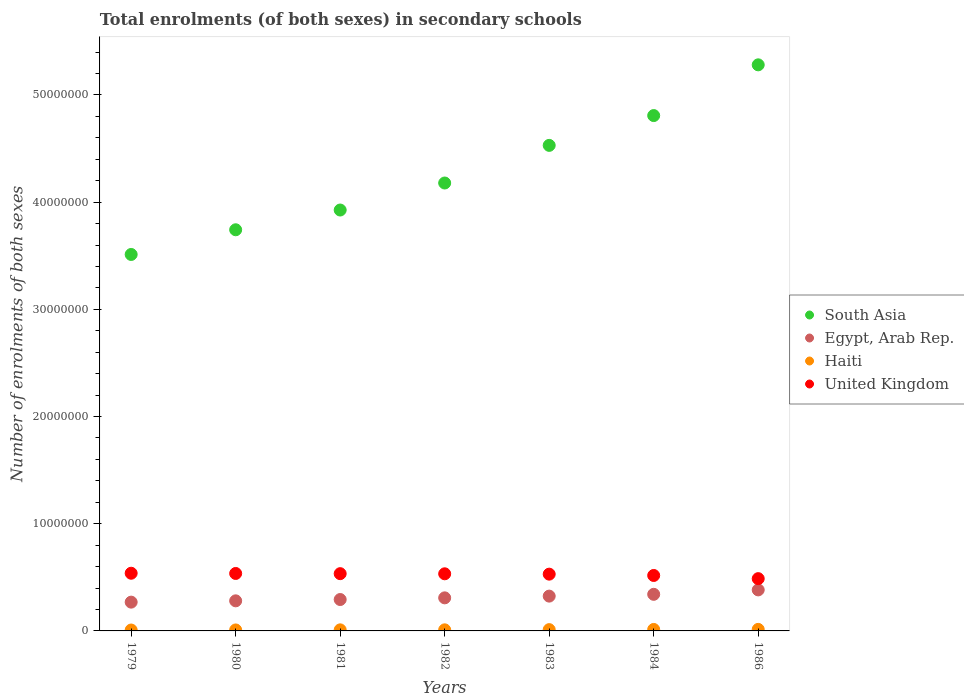Is the number of dotlines equal to the number of legend labels?
Offer a very short reply. Yes. What is the number of enrolments in secondary schools in Haiti in 1981?
Keep it short and to the point. 9.99e+04. Across all years, what is the maximum number of enrolments in secondary schools in Egypt, Arab Rep.?
Your response must be concise. 3.83e+06. Across all years, what is the minimum number of enrolments in secondary schools in United Kingdom?
Your answer should be very brief. 4.88e+06. In which year was the number of enrolments in secondary schools in South Asia maximum?
Your answer should be compact. 1986. In which year was the number of enrolments in secondary schools in Egypt, Arab Rep. minimum?
Make the answer very short. 1979. What is the total number of enrolments in secondary schools in South Asia in the graph?
Offer a very short reply. 3.00e+08. What is the difference between the number of enrolments in secondary schools in Egypt, Arab Rep. in 1982 and that in 1984?
Your response must be concise. -3.29e+05. What is the difference between the number of enrolments in secondary schools in South Asia in 1984 and the number of enrolments in secondary schools in Haiti in 1983?
Your answer should be very brief. 4.80e+07. What is the average number of enrolments in secondary schools in Haiti per year?
Your answer should be very brief. 1.11e+05. In the year 1981, what is the difference between the number of enrolments in secondary schools in Haiti and number of enrolments in secondary schools in Egypt, Arab Rep.?
Your answer should be compact. -2.83e+06. In how many years, is the number of enrolments in secondary schools in United Kingdom greater than 50000000?
Your answer should be very brief. 0. What is the ratio of the number of enrolments in secondary schools in South Asia in 1982 to that in 1983?
Make the answer very short. 0.92. What is the difference between the highest and the second highest number of enrolments in secondary schools in Egypt, Arab Rep.?
Your response must be concise. 4.12e+05. What is the difference between the highest and the lowest number of enrolments in secondary schools in Haiti?
Provide a succinct answer. 5.93e+04. In how many years, is the number of enrolments in secondary schools in Egypt, Arab Rep. greater than the average number of enrolments in secondary schools in Egypt, Arab Rep. taken over all years?
Provide a succinct answer. 3. Is it the case that in every year, the sum of the number of enrolments in secondary schools in United Kingdom and number of enrolments in secondary schools in Haiti  is greater than the sum of number of enrolments in secondary schools in South Asia and number of enrolments in secondary schools in Egypt, Arab Rep.?
Offer a very short reply. No. How many years are there in the graph?
Offer a very short reply. 7. Are the values on the major ticks of Y-axis written in scientific E-notation?
Your response must be concise. No. Does the graph contain any zero values?
Provide a succinct answer. No. Does the graph contain grids?
Your response must be concise. No. How many legend labels are there?
Ensure brevity in your answer.  4. How are the legend labels stacked?
Ensure brevity in your answer.  Vertical. What is the title of the graph?
Give a very brief answer. Total enrolments (of both sexes) in secondary schools. Does "Uganda" appear as one of the legend labels in the graph?
Your answer should be very brief. No. What is the label or title of the Y-axis?
Provide a short and direct response. Number of enrolments of both sexes. What is the Number of enrolments of both sexes of South Asia in 1979?
Provide a succinct answer. 3.51e+07. What is the Number of enrolments of both sexes in Egypt, Arab Rep. in 1979?
Provide a short and direct response. 2.69e+06. What is the Number of enrolments of both sexes of Haiti in 1979?
Give a very brief answer. 8.45e+04. What is the Number of enrolments of both sexes of United Kingdom in 1979?
Make the answer very short. 5.38e+06. What is the Number of enrolments of both sexes in South Asia in 1980?
Ensure brevity in your answer.  3.74e+07. What is the Number of enrolments of both sexes in Egypt, Arab Rep. in 1980?
Your response must be concise. 2.81e+06. What is the Number of enrolments of both sexes of Haiti in 1980?
Offer a very short reply. 9.12e+04. What is the Number of enrolments of both sexes in United Kingdom in 1980?
Offer a very short reply. 5.36e+06. What is the Number of enrolments of both sexes of South Asia in 1981?
Offer a terse response. 3.93e+07. What is the Number of enrolments of both sexes in Egypt, Arab Rep. in 1981?
Offer a very short reply. 2.93e+06. What is the Number of enrolments of both sexes of Haiti in 1981?
Your answer should be compact. 9.99e+04. What is the Number of enrolments of both sexes of United Kingdom in 1981?
Offer a very short reply. 5.34e+06. What is the Number of enrolments of both sexes of South Asia in 1982?
Keep it short and to the point. 4.18e+07. What is the Number of enrolments of both sexes of Egypt, Arab Rep. in 1982?
Provide a short and direct response. 3.09e+06. What is the Number of enrolments of both sexes of Haiti in 1982?
Keep it short and to the point. 1.02e+05. What is the Number of enrolments of both sexes in United Kingdom in 1982?
Offer a very short reply. 5.33e+06. What is the Number of enrolments of both sexes of South Asia in 1983?
Keep it short and to the point. 4.53e+07. What is the Number of enrolments of both sexes in Egypt, Arab Rep. in 1983?
Your answer should be very brief. 3.25e+06. What is the Number of enrolments of both sexes of Haiti in 1983?
Give a very brief answer. 1.20e+05. What is the Number of enrolments of both sexes of United Kingdom in 1983?
Your answer should be compact. 5.30e+06. What is the Number of enrolments of both sexes in South Asia in 1984?
Make the answer very short. 4.81e+07. What is the Number of enrolments of both sexes in Egypt, Arab Rep. in 1984?
Your answer should be compact. 3.41e+06. What is the Number of enrolments of both sexes in Haiti in 1984?
Give a very brief answer. 1.38e+05. What is the Number of enrolments of both sexes in United Kingdom in 1984?
Offer a very short reply. 5.17e+06. What is the Number of enrolments of both sexes in South Asia in 1986?
Ensure brevity in your answer.  5.28e+07. What is the Number of enrolments of both sexes of Egypt, Arab Rep. in 1986?
Offer a terse response. 3.83e+06. What is the Number of enrolments of both sexes of Haiti in 1986?
Provide a succinct answer. 1.44e+05. What is the Number of enrolments of both sexes in United Kingdom in 1986?
Give a very brief answer. 4.88e+06. Across all years, what is the maximum Number of enrolments of both sexes of South Asia?
Make the answer very short. 5.28e+07. Across all years, what is the maximum Number of enrolments of both sexes of Egypt, Arab Rep.?
Ensure brevity in your answer.  3.83e+06. Across all years, what is the maximum Number of enrolments of both sexes in Haiti?
Provide a succinct answer. 1.44e+05. Across all years, what is the maximum Number of enrolments of both sexes of United Kingdom?
Give a very brief answer. 5.38e+06. Across all years, what is the minimum Number of enrolments of both sexes in South Asia?
Offer a terse response. 3.51e+07. Across all years, what is the minimum Number of enrolments of both sexes in Egypt, Arab Rep.?
Offer a terse response. 2.69e+06. Across all years, what is the minimum Number of enrolments of both sexes of Haiti?
Keep it short and to the point. 8.45e+04. Across all years, what is the minimum Number of enrolments of both sexes of United Kingdom?
Make the answer very short. 4.88e+06. What is the total Number of enrolments of both sexes in South Asia in the graph?
Ensure brevity in your answer.  3.00e+08. What is the total Number of enrolments of both sexes in Egypt, Arab Rep. in the graph?
Provide a succinct answer. 2.20e+07. What is the total Number of enrolments of both sexes of Haiti in the graph?
Ensure brevity in your answer.  7.79e+05. What is the total Number of enrolments of both sexes in United Kingdom in the graph?
Make the answer very short. 3.68e+07. What is the difference between the Number of enrolments of both sexes of South Asia in 1979 and that in 1980?
Offer a terse response. -2.30e+06. What is the difference between the Number of enrolments of both sexes in Egypt, Arab Rep. in 1979 and that in 1980?
Give a very brief answer. -1.22e+05. What is the difference between the Number of enrolments of both sexes of Haiti in 1979 and that in 1980?
Your answer should be very brief. -6793. What is the difference between the Number of enrolments of both sexes of United Kingdom in 1979 and that in 1980?
Provide a succinct answer. 2.07e+04. What is the difference between the Number of enrolments of both sexes in South Asia in 1979 and that in 1981?
Ensure brevity in your answer.  -4.15e+06. What is the difference between the Number of enrolments of both sexes in Egypt, Arab Rep. in 1979 and that in 1981?
Ensure brevity in your answer.  -2.44e+05. What is the difference between the Number of enrolments of both sexes of Haiti in 1979 and that in 1981?
Your answer should be very brief. -1.54e+04. What is the difference between the Number of enrolments of both sexes of United Kingdom in 1979 and that in 1981?
Offer a very short reply. 3.89e+04. What is the difference between the Number of enrolments of both sexes of South Asia in 1979 and that in 1982?
Your answer should be very brief. -6.67e+06. What is the difference between the Number of enrolments of both sexes in Egypt, Arab Rep. in 1979 and that in 1982?
Provide a short and direct response. -4.00e+05. What is the difference between the Number of enrolments of both sexes of Haiti in 1979 and that in 1982?
Make the answer very short. -1.71e+04. What is the difference between the Number of enrolments of both sexes in United Kingdom in 1979 and that in 1982?
Your response must be concise. 5.15e+04. What is the difference between the Number of enrolments of both sexes of South Asia in 1979 and that in 1983?
Ensure brevity in your answer.  -1.02e+07. What is the difference between the Number of enrolments of both sexes in Egypt, Arab Rep. in 1979 and that in 1983?
Your answer should be very brief. -5.61e+05. What is the difference between the Number of enrolments of both sexes of Haiti in 1979 and that in 1983?
Provide a succinct answer. -3.59e+04. What is the difference between the Number of enrolments of both sexes in United Kingdom in 1979 and that in 1983?
Provide a short and direct response. 8.48e+04. What is the difference between the Number of enrolments of both sexes of South Asia in 1979 and that in 1984?
Provide a succinct answer. -1.30e+07. What is the difference between the Number of enrolments of both sexes of Egypt, Arab Rep. in 1979 and that in 1984?
Provide a succinct answer. -7.29e+05. What is the difference between the Number of enrolments of both sexes in Haiti in 1979 and that in 1984?
Keep it short and to the point. -5.31e+04. What is the difference between the Number of enrolments of both sexes in United Kingdom in 1979 and that in 1984?
Make the answer very short. 2.08e+05. What is the difference between the Number of enrolments of both sexes in South Asia in 1979 and that in 1986?
Your answer should be compact. -1.77e+07. What is the difference between the Number of enrolments of both sexes of Egypt, Arab Rep. in 1979 and that in 1986?
Offer a terse response. -1.14e+06. What is the difference between the Number of enrolments of both sexes of Haiti in 1979 and that in 1986?
Your answer should be very brief. -5.93e+04. What is the difference between the Number of enrolments of both sexes in United Kingdom in 1979 and that in 1986?
Your response must be concise. 5.04e+05. What is the difference between the Number of enrolments of both sexes of South Asia in 1980 and that in 1981?
Give a very brief answer. -1.84e+06. What is the difference between the Number of enrolments of both sexes in Egypt, Arab Rep. in 1980 and that in 1981?
Keep it short and to the point. -1.22e+05. What is the difference between the Number of enrolments of both sexes of Haiti in 1980 and that in 1981?
Offer a terse response. -8647. What is the difference between the Number of enrolments of both sexes of United Kingdom in 1980 and that in 1981?
Your answer should be very brief. 1.82e+04. What is the difference between the Number of enrolments of both sexes in South Asia in 1980 and that in 1982?
Give a very brief answer. -4.36e+06. What is the difference between the Number of enrolments of both sexes of Egypt, Arab Rep. in 1980 and that in 1982?
Your response must be concise. -2.78e+05. What is the difference between the Number of enrolments of both sexes in Haiti in 1980 and that in 1982?
Make the answer very short. -1.03e+04. What is the difference between the Number of enrolments of both sexes in United Kingdom in 1980 and that in 1982?
Keep it short and to the point. 3.08e+04. What is the difference between the Number of enrolments of both sexes in South Asia in 1980 and that in 1983?
Provide a short and direct response. -7.87e+06. What is the difference between the Number of enrolments of both sexes of Egypt, Arab Rep. in 1980 and that in 1983?
Your answer should be very brief. -4.39e+05. What is the difference between the Number of enrolments of both sexes of Haiti in 1980 and that in 1983?
Give a very brief answer. -2.91e+04. What is the difference between the Number of enrolments of both sexes in United Kingdom in 1980 and that in 1983?
Offer a terse response. 6.41e+04. What is the difference between the Number of enrolments of both sexes of South Asia in 1980 and that in 1984?
Provide a short and direct response. -1.07e+07. What is the difference between the Number of enrolments of both sexes in Egypt, Arab Rep. in 1980 and that in 1984?
Your answer should be compact. -6.08e+05. What is the difference between the Number of enrolments of both sexes of Haiti in 1980 and that in 1984?
Give a very brief answer. -4.63e+04. What is the difference between the Number of enrolments of both sexes of United Kingdom in 1980 and that in 1984?
Ensure brevity in your answer.  1.87e+05. What is the difference between the Number of enrolments of both sexes of South Asia in 1980 and that in 1986?
Offer a very short reply. -1.54e+07. What is the difference between the Number of enrolments of both sexes of Egypt, Arab Rep. in 1980 and that in 1986?
Your answer should be compact. -1.02e+06. What is the difference between the Number of enrolments of both sexes in Haiti in 1980 and that in 1986?
Make the answer very short. -5.25e+04. What is the difference between the Number of enrolments of both sexes of United Kingdom in 1980 and that in 1986?
Provide a succinct answer. 4.83e+05. What is the difference between the Number of enrolments of both sexes in South Asia in 1981 and that in 1982?
Offer a terse response. -2.52e+06. What is the difference between the Number of enrolments of both sexes in Egypt, Arab Rep. in 1981 and that in 1982?
Your answer should be very brief. -1.56e+05. What is the difference between the Number of enrolments of both sexes of Haiti in 1981 and that in 1982?
Keep it short and to the point. -1625. What is the difference between the Number of enrolments of both sexes in United Kingdom in 1981 and that in 1982?
Keep it short and to the point. 1.26e+04. What is the difference between the Number of enrolments of both sexes of South Asia in 1981 and that in 1983?
Keep it short and to the point. -6.03e+06. What is the difference between the Number of enrolments of both sexes of Egypt, Arab Rep. in 1981 and that in 1983?
Provide a short and direct response. -3.17e+05. What is the difference between the Number of enrolments of both sexes of Haiti in 1981 and that in 1983?
Provide a short and direct response. -2.04e+04. What is the difference between the Number of enrolments of both sexes in United Kingdom in 1981 and that in 1983?
Your response must be concise. 4.58e+04. What is the difference between the Number of enrolments of both sexes in South Asia in 1981 and that in 1984?
Offer a terse response. -8.81e+06. What is the difference between the Number of enrolments of both sexes of Egypt, Arab Rep. in 1981 and that in 1984?
Give a very brief answer. -4.86e+05. What is the difference between the Number of enrolments of both sexes of Haiti in 1981 and that in 1984?
Provide a succinct answer. -3.76e+04. What is the difference between the Number of enrolments of both sexes in United Kingdom in 1981 and that in 1984?
Provide a short and direct response. 1.69e+05. What is the difference between the Number of enrolments of both sexes in South Asia in 1981 and that in 1986?
Offer a terse response. -1.35e+07. What is the difference between the Number of enrolments of both sexes of Egypt, Arab Rep. in 1981 and that in 1986?
Keep it short and to the point. -8.97e+05. What is the difference between the Number of enrolments of both sexes of Haiti in 1981 and that in 1986?
Keep it short and to the point. -4.39e+04. What is the difference between the Number of enrolments of both sexes in United Kingdom in 1981 and that in 1986?
Give a very brief answer. 4.65e+05. What is the difference between the Number of enrolments of both sexes of South Asia in 1982 and that in 1983?
Ensure brevity in your answer.  -3.51e+06. What is the difference between the Number of enrolments of both sexes in Egypt, Arab Rep. in 1982 and that in 1983?
Your answer should be compact. -1.61e+05. What is the difference between the Number of enrolments of both sexes of Haiti in 1982 and that in 1983?
Your response must be concise. -1.88e+04. What is the difference between the Number of enrolments of both sexes of United Kingdom in 1982 and that in 1983?
Offer a very short reply. 3.33e+04. What is the difference between the Number of enrolments of both sexes in South Asia in 1982 and that in 1984?
Make the answer very short. -6.29e+06. What is the difference between the Number of enrolments of both sexes in Egypt, Arab Rep. in 1982 and that in 1984?
Make the answer very short. -3.29e+05. What is the difference between the Number of enrolments of both sexes in Haiti in 1982 and that in 1984?
Keep it short and to the point. -3.60e+04. What is the difference between the Number of enrolments of both sexes in United Kingdom in 1982 and that in 1984?
Ensure brevity in your answer.  1.56e+05. What is the difference between the Number of enrolments of both sexes of South Asia in 1982 and that in 1986?
Offer a terse response. -1.10e+07. What is the difference between the Number of enrolments of both sexes of Egypt, Arab Rep. in 1982 and that in 1986?
Ensure brevity in your answer.  -7.41e+05. What is the difference between the Number of enrolments of both sexes in Haiti in 1982 and that in 1986?
Provide a short and direct response. -4.22e+04. What is the difference between the Number of enrolments of both sexes of United Kingdom in 1982 and that in 1986?
Make the answer very short. 4.52e+05. What is the difference between the Number of enrolments of both sexes of South Asia in 1983 and that in 1984?
Offer a terse response. -2.78e+06. What is the difference between the Number of enrolments of both sexes in Egypt, Arab Rep. in 1983 and that in 1984?
Offer a terse response. -1.68e+05. What is the difference between the Number of enrolments of both sexes of Haiti in 1983 and that in 1984?
Offer a terse response. -1.72e+04. What is the difference between the Number of enrolments of both sexes in United Kingdom in 1983 and that in 1984?
Ensure brevity in your answer.  1.23e+05. What is the difference between the Number of enrolments of both sexes of South Asia in 1983 and that in 1986?
Give a very brief answer. -7.51e+06. What is the difference between the Number of enrolments of both sexes in Egypt, Arab Rep. in 1983 and that in 1986?
Offer a terse response. -5.80e+05. What is the difference between the Number of enrolments of both sexes in Haiti in 1983 and that in 1986?
Provide a short and direct response. -2.34e+04. What is the difference between the Number of enrolments of both sexes in United Kingdom in 1983 and that in 1986?
Make the answer very short. 4.19e+05. What is the difference between the Number of enrolments of both sexes of South Asia in 1984 and that in 1986?
Offer a very short reply. -4.73e+06. What is the difference between the Number of enrolments of both sexes in Egypt, Arab Rep. in 1984 and that in 1986?
Make the answer very short. -4.12e+05. What is the difference between the Number of enrolments of both sexes in Haiti in 1984 and that in 1986?
Provide a short and direct response. -6245. What is the difference between the Number of enrolments of both sexes of United Kingdom in 1984 and that in 1986?
Your answer should be compact. 2.96e+05. What is the difference between the Number of enrolments of both sexes of South Asia in 1979 and the Number of enrolments of both sexes of Egypt, Arab Rep. in 1980?
Your answer should be very brief. 3.23e+07. What is the difference between the Number of enrolments of both sexes in South Asia in 1979 and the Number of enrolments of both sexes in Haiti in 1980?
Provide a succinct answer. 3.50e+07. What is the difference between the Number of enrolments of both sexes of South Asia in 1979 and the Number of enrolments of both sexes of United Kingdom in 1980?
Ensure brevity in your answer.  2.98e+07. What is the difference between the Number of enrolments of both sexes of Egypt, Arab Rep. in 1979 and the Number of enrolments of both sexes of Haiti in 1980?
Provide a succinct answer. 2.59e+06. What is the difference between the Number of enrolments of both sexes in Egypt, Arab Rep. in 1979 and the Number of enrolments of both sexes in United Kingdom in 1980?
Your answer should be very brief. -2.67e+06. What is the difference between the Number of enrolments of both sexes in Haiti in 1979 and the Number of enrolments of both sexes in United Kingdom in 1980?
Your answer should be compact. -5.28e+06. What is the difference between the Number of enrolments of both sexes of South Asia in 1979 and the Number of enrolments of both sexes of Egypt, Arab Rep. in 1981?
Your answer should be compact. 3.22e+07. What is the difference between the Number of enrolments of both sexes of South Asia in 1979 and the Number of enrolments of both sexes of Haiti in 1981?
Offer a very short reply. 3.50e+07. What is the difference between the Number of enrolments of both sexes in South Asia in 1979 and the Number of enrolments of both sexes in United Kingdom in 1981?
Offer a terse response. 2.98e+07. What is the difference between the Number of enrolments of both sexes of Egypt, Arab Rep. in 1979 and the Number of enrolments of both sexes of Haiti in 1981?
Provide a succinct answer. 2.59e+06. What is the difference between the Number of enrolments of both sexes in Egypt, Arab Rep. in 1979 and the Number of enrolments of both sexes in United Kingdom in 1981?
Provide a short and direct response. -2.66e+06. What is the difference between the Number of enrolments of both sexes in Haiti in 1979 and the Number of enrolments of both sexes in United Kingdom in 1981?
Ensure brevity in your answer.  -5.26e+06. What is the difference between the Number of enrolments of both sexes in South Asia in 1979 and the Number of enrolments of both sexes in Egypt, Arab Rep. in 1982?
Provide a succinct answer. 3.20e+07. What is the difference between the Number of enrolments of both sexes of South Asia in 1979 and the Number of enrolments of both sexes of Haiti in 1982?
Ensure brevity in your answer.  3.50e+07. What is the difference between the Number of enrolments of both sexes in South Asia in 1979 and the Number of enrolments of both sexes in United Kingdom in 1982?
Ensure brevity in your answer.  2.98e+07. What is the difference between the Number of enrolments of both sexes in Egypt, Arab Rep. in 1979 and the Number of enrolments of both sexes in Haiti in 1982?
Your answer should be compact. 2.58e+06. What is the difference between the Number of enrolments of both sexes in Egypt, Arab Rep. in 1979 and the Number of enrolments of both sexes in United Kingdom in 1982?
Your answer should be compact. -2.64e+06. What is the difference between the Number of enrolments of both sexes of Haiti in 1979 and the Number of enrolments of both sexes of United Kingdom in 1982?
Make the answer very short. -5.24e+06. What is the difference between the Number of enrolments of both sexes of South Asia in 1979 and the Number of enrolments of both sexes of Egypt, Arab Rep. in 1983?
Keep it short and to the point. 3.19e+07. What is the difference between the Number of enrolments of both sexes of South Asia in 1979 and the Number of enrolments of both sexes of Haiti in 1983?
Make the answer very short. 3.50e+07. What is the difference between the Number of enrolments of both sexes of South Asia in 1979 and the Number of enrolments of both sexes of United Kingdom in 1983?
Offer a very short reply. 2.98e+07. What is the difference between the Number of enrolments of both sexes of Egypt, Arab Rep. in 1979 and the Number of enrolments of both sexes of Haiti in 1983?
Your answer should be compact. 2.56e+06. What is the difference between the Number of enrolments of both sexes of Egypt, Arab Rep. in 1979 and the Number of enrolments of both sexes of United Kingdom in 1983?
Offer a terse response. -2.61e+06. What is the difference between the Number of enrolments of both sexes of Haiti in 1979 and the Number of enrolments of both sexes of United Kingdom in 1983?
Make the answer very short. -5.21e+06. What is the difference between the Number of enrolments of both sexes of South Asia in 1979 and the Number of enrolments of both sexes of Egypt, Arab Rep. in 1984?
Keep it short and to the point. 3.17e+07. What is the difference between the Number of enrolments of both sexes of South Asia in 1979 and the Number of enrolments of both sexes of Haiti in 1984?
Your response must be concise. 3.50e+07. What is the difference between the Number of enrolments of both sexes in South Asia in 1979 and the Number of enrolments of both sexes in United Kingdom in 1984?
Your answer should be compact. 2.99e+07. What is the difference between the Number of enrolments of both sexes of Egypt, Arab Rep. in 1979 and the Number of enrolments of both sexes of Haiti in 1984?
Offer a very short reply. 2.55e+06. What is the difference between the Number of enrolments of both sexes of Egypt, Arab Rep. in 1979 and the Number of enrolments of both sexes of United Kingdom in 1984?
Provide a succinct answer. -2.49e+06. What is the difference between the Number of enrolments of both sexes of Haiti in 1979 and the Number of enrolments of both sexes of United Kingdom in 1984?
Your response must be concise. -5.09e+06. What is the difference between the Number of enrolments of both sexes in South Asia in 1979 and the Number of enrolments of both sexes in Egypt, Arab Rep. in 1986?
Keep it short and to the point. 3.13e+07. What is the difference between the Number of enrolments of both sexes in South Asia in 1979 and the Number of enrolments of both sexes in Haiti in 1986?
Your answer should be compact. 3.50e+07. What is the difference between the Number of enrolments of both sexes in South Asia in 1979 and the Number of enrolments of both sexes in United Kingdom in 1986?
Your answer should be very brief. 3.02e+07. What is the difference between the Number of enrolments of both sexes in Egypt, Arab Rep. in 1979 and the Number of enrolments of both sexes in Haiti in 1986?
Your answer should be compact. 2.54e+06. What is the difference between the Number of enrolments of both sexes in Egypt, Arab Rep. in 1979 and the Number of enrolments of both sexes in United Kingdom in 1986?
Your answer should be very brief. -2.19e+06. What is the difference between the Number of enrolments of both sexes in Haiti in 1979 and the Number of enrolments of both sexes in United Kingdom in 1986?
Make the answer very short. -4.79e+06. What is the difference between the Number of enrolments of both sexes of South Asia in 1980 and the Number of enrolments of both sexes of Egypt, Arab Rep. in 1981?
Make the answer very short. 3.45e+07. What is the difference between the Number of enrolments of both sexes of South Asia in 1980 and the Number of enrolments of both sexes of Haiti in 1981?
Your answer should be very brief. 3.73e+07. What is the difference between the Number of enrolments of both sexes in South Asia in 1980 and the Number of enrolments of both sexes in United Kingdom in 1981?
Offer a very short reply. 3.21e+07. What is the difference between the Number of enrolments of both sexes in Egypt, Arab Rep. in 1980 and the Number of enrolments of both sexes in Haiti in 1981?
Your answer should be very brief. 2.71e+06. What is the difference between the Number of enrolments of both sexes of Egypt, Arab Rep. in 1980 and the Number of enrolments of both sexes of United Kingdom in 1981?
Provide a succinct answer. -2.53e+06. What is the difference between the Number of enrolments of both sexes in Haiti in 1980 and the Number of enrolments of both sexes in United Kingdom in 1981?
Your response must be concise. -5.25e+06. What is the difference between the Number of enrolments of both sexes of South Asia in 1980 and the Number of enrolments of both sexes of Egypt, Arab Rep. in 1982?
Ensure brevity in your answer.  3.43e+07. What is the difference between the Number of enrolments of both sexes of South Asia in 1980 and the Number of enrolments of both sexes of Haiti in 1982?
Your answer should be compact. 3.73e+07. What is the difference between the Number of enrolments of both sexes of South Asia in 1980 and the Number of enrolments of both sexes of United Kingdom in 1982?
Give a very brief answer. 3.21e+07. What is the difference between the Number of enrolments of both sexes of Egypt, Arab Rep. in 1980 and the Number of enrolments of both sexes of Haiti in 1982?
Offer a very short reply. 2.71e+06. What is the difference between the Number of enrolments of both sexes of Egypt, Arab Rep. in 1980 and the Number of enrolments of both sexes of United Kingdom in 1982?
Offer a very short reply. -2.52e+06. What is the difference between the Number of enrolments of both sexes of Haiti in 1980 and the Number of enrolments of both sexes of United Kingdom in 1982?
Offer a terse response. -5.24e+06. What is the difference between the Number of enrolments of both sexes in South Asia in 1980 and the Number of enrolments of both sexes in Egypt, Arab Rep. in 1983?
Give a very brief answer. 3.42e+07. What is the difference between the Number of enrolments of both sexes of South Asia in 1980 and the Number of enrolments of both sexes of Haiti in 1983?
Keep it short and to the point. 3.73e+07. What is the difference between the Number of enrolments of both sexes of South Asia in 1980 and the Number of enrolments of both sexes of United Kingdom in 1983?
Your answer should be compact. 3.21e+07. What is the difference between the Number of enrolments of both sexes of Egypt, Arab Rep. in 1980 and the Number of enrolments of both sexes of Haiti in 1983?
Provide a short and direct response. 2.69e+06. What is the difference between the Number of enrolments of both sexes of Egypt, Arab Rep. in 1980 and the Number of enrolments of both sexes of United Kingdom in 1983?
Offer a terse response. -2.49e+06. What is the difference between the Number of enrolments of both sexes of Haiti in 1980 and the Number of enrolments of both sexes of United Kingdom in 1983?
Make the answer very short. -5.20e+06. What is the difference between the Number of enrolments of both sexes in South Asia in 1980 and the Number of enrolments of both sexes in Egypt, Arab Rep. in 1984?
Offer a very short reply. 3.40e+07. What is the difference between the Number of enrolments of both sexes of South Asia in 1980 and the Number of enrolments of both sexes of Haiti in 1984?
Provide a short and direct response. 3.73e+07. What is the difference between the Number of enrolments of both sexes in South Asia in 1980 and the Number of enrolments of both sexes in United Kingdom in 1984?
Offer a very short reply. 3.23e+07. What is the difference between the Number of enrolments of both sexes in Egypt, Arab Rep. in 1980 and the Number of enrolments of both sexes in Haiti in 1984?
Ensure brevity in your answer.  2.67e+06. What is the difference between the Number of enrolments of both sexes in Egypt, Arab Rep. in 1980 and the Number of enrolments of both sexes in United Kingdom in 1984?
Make the answer very short. -2.37e+06. What is the difference between the Number of enrolments of both sexes of Haiti in 1980 and the Number of enrolments of both sexes of United Kingdom in 1984?
Ensure brevity in your answer.  -5.08e+06. What is the difference between the Number of enrolments of both sexes of South Asia in 1980 and the Number of enrolments of both sexes of Egypt, Arab Rep. in 1986?
Your answer should be compact. 3.36e+07. What is the difference between the Number of enrolments of both sexes in South Asia in 1980 and the Number of enrolments of both sexes in Haiti in 1986?
Make the answer very short. 3.73e+07. What is the difference between the Number of enrolments of both sexes of South Asia in 1980 and the Number of enrolments of both sexes of United Kingdom in 1986?
Your answer should be very brief. 3.25e+07. What is the difference between the Number of enrolments of both sexes in Egypt, Arab Rep. in 1980 and the Number of enrolments of both sexes in Haiti in 1986?
Give a very brief answer. 2.66e+06. What is the difference between the Number of enrolments of both sexes of Egypt, Arab Rep. in 1980 and the Number of enrolments of both sexes of United Kingdom in 1986?
Your answer should be very brief. -2.07e+06. What is the difference between the Number of enrolments of both sexes of Haiti in 1980 and the Number of enrolments of both sexes of United Kingdom in 1986?
Your answer should be compact. -4.79e+06. What is the difference between the Number of enrolments of both sexes of South Asia in 1981 and the Number of enrolments of both sexes of Egypt, Arab Rep. in 1982?
Provide a succinct answer. 3.62e+07. What is the difference between the Number of enrolments of both sexes of South Asia in 1981 and the Number of enrolments of both sexes of Haiti in 1982?
Your answer should be compact. 3.92e+07. What is the difference between the Number of enrolments of both sexes of South Asia in 1981 and the Number of enrolments of both sexes of United Kingdom in 1982?
Offer a terse response. 3.39e+07. What is the difference between the Number of enrolments of both sexes of Egypt, Arab Rep. in 1981 and the Number of enrolments of both sexes of Haiti in 1982?
Offer a terse response. 2.83e+06. What is the difference between the Number of enrolments of both sexes in Egypt, Arab Rep. in 1981 and the Number of enrolments of both sexes in United Kingdom in 1982?
Keep it short and to the point. -2.40e+06. What is the difference between the Number of enrolments of both sexes in Haiti in 1981 and the Number of enrolments of both sexes in United Kingdom in 1982?
Offer a very short reply. -5.23e+06. What is the difference between the Number of enrolments of both sexes of South Asia in 1981 and the Number of enrolments of both sexes of Egypt, Arab Rep. in 1983?
Your response must be concise. 3.60e+07. What is the difference between the Number of enrolments of both sexes of South Asia in 1981 and the Number of enrolments of both sexes of Haiti in 1983?
Give a very brief answer. 3.91e+07. What is the difference between the Number of enrolments of both sexes of South Asia in 1981 and the Number of enrolments of both sexes of United Kingdom in 1983?
Ensure brevity in your answer.  3.40e+07. What is the difference between the Number of enrolments of both sexes in Egypt, Arab Rep. in 1981 and the Number of enrolments of both sexes in Haiti in 1983?
Provide a short and direct response. 2.81e+06. What is the difference between the Number of enrolments of both sexes of Egypt, Arab Rep. in 1981 and the Number of enrolments of both sexes of United Kingdom in 1983?
Ensure brevity in your answer.  -2.37e+06. What is the difference between the Number of enrolments of both sexes of Haiti in 1981 and the Number of enrolments of both sexes of United Kingdom in 1983?
Ensure brevity in your answer.  -5.20e+06. What is the difference between the Number of enrolments of both sexes of South Asia in 1981 and the Number of enrolments of both sexes of Egypt, Arab Rep. in 1984?
Offer a very short reply. 3.59e+07. What is the difference between the Number of enrolments of both sexes of South Asia in 1981 and the Number of enrolments of both sexes of Haiti in 1984?
Provide a short and direct response. 3.91e+07. What is the difference between the Number of enrolments of both sexes of South Asia in 1981 and the Number of enrolments of both sexes of United Kingdom in 1984?
Your answer should be very brief. 3.41e+07. What is the difference between the Number of enrolments of both sexes in Egypt, Arab Rep. in 1981 and the Number of enrolments of both sexes in Haiti in 1984?
Your answer should be very brief. 2.79e+06. What is the difference between the Number of enrolments of both sexes of Egypt, Arab Rep. in 1981 and the Number of enrolments of both sexes of United Kingdom in 1984?
Keep it short and to the point. -2.24e+06. What is the difference between the Number of enrolments of both sexes of Haiti in 1981 and the Number of enrolments of both sexes of United Kingdom in 1984?
Provide a succinct answer. -5.07e+06. What is the difference between the Number of enrolments of both sexes in South Asia in 1981 and the Number of enrolments of both sexes in Egypt, Arab Rep. in 1986?
Offer a very short reply. 3.54e+07. What is the difference between the Number of enrolments of both sexes in South Asia in 1981 and the Number of enrolments of both sexes in Haiti in 1986?
Offer a very short reply. 3.91e+07. What is the difference between the Number of enrolments of both sexes of South Asia in 1981 and the Number of enrolments of both sexes of United Kingdom in 1986?
Ensure brevity in your answer.  3.44e+07. What is the difference between the Number of enrolments of both sexes in Egypt, Arab Rep. in 1981 and the Number of enrolments of both sexes in Haiti in 1986?
Provide a short and direct response. 2.79e+06. What is the difference between the Number of enrolments of both sexes of Egypt, Arab Rep. in 1981 and the Number of enrolments of both sexes of United Kingdom in 1986?
Provide a succinct answer. -1.95e+06. What is the difference between the Number of enrolments of both sexes of Haiti in 1981 and the Number of enrolments of both sexes of United Kingdom in 1986?
Ensure brevity in your answer.  -4.78e+06. What is the difference between the Number of enrolments of both sexes of South Asia in 1982 and the Number of enrolments of both sexes of Egypt, Arab Rep. in 1983?
Ensure brevity in your answer.  3.85e+07. What is the difference between the Number of enrolments of both sexes of South Asia in 1982 and the Number of enrolments of both sexes of Haiti in 1983?
Keep it short and to the point. 4.17e+07. What is the difference between the Number of enrolments of both sexes in South Asia in 1982 and the Number of enrolments of both sexes in United Kingdom in 1983?
Ensure brevity in your answer.  3.65e+07. What is the difference between the Number of enrolments of both sexes in Egypt, Arab Rep. in 1982 and the Number of enrolments of both sexes in Haiti in 1983?
Provide a short and direct response. 2.97e+06. What is the difference between the Number of enrolments of both sexes in Egypt, Arab Rep. in 1982 and the Number of enrolments of both sexes in United Kingdom in 1983?
Keep it short and to the point. -2.21e+06. What is the difference between the Number of enrolments of both sexes of Haiti in 1982 and the Number of enrolments of both sexes of United Kingdom in 1983?
Keep it short and to the point. -5.19e+06. What is the difference between the Number of enrolments of both sexes of South Asia in 1982 and the Number of enrolments of both sexes of Egypt, Arab Rep. in 1984?
Keep it short and to the point. 3.84e+07. What is the difference between the Number of enrolments of both sexes of South Asia in 1982 and the Number of enrolments of both sexes of Haiti in 1984?
Ensure brevity in your answer.  4.17e+07. What is the difference between the Number of enrolments of both sexes of South Asia in 1982 and the Number of enrolments of both sexes of United Kingdom in 1984?
Provide a succinct answer. 3.66e+07. What is the difference between the Number of enrolments of both sexes in Egypt, Arab Rep. in 1982 and the Number of enrolments of both sexes in Haiti in 1984?
Offer a very short reply. 2.95e+06. What is the difference between the Number of enrolments of both sexes in Egypt, Arab Rep. in 1982 and the Number of enrolments of both sexes in United Kingdom in 1984?
Give a very brief answer. -2.09e+06. What is the difference between the Number of enrolments of both sexes of Haiti in 1982 and the Number of enrolments of both sexes of United Kingdom in 1984?
Your response must be concise. -5.07e+06. What is the difference between the Number of enrolments of both sexes of South Asia in 1982 and the Number of enrolments of both sexes of Egypt, Arab Rep. in 1986?
Keep it short and to the point. 3.80e+07. What is the difference between the Number of enrolments of both sexes in South Asia in 1982 and the Number of enrolments of both sexes in Haiti in 1986?
Your answer should be compact. 4.16e+07. What is the difference between the Number of enrolments of both sexes in South Asia in 1982 and the Number of enrolments of both sexes in United Kingdom in 1986?
Give a very brief answer. 3.69e+07. What is the difference between the Number of enrolments of both sexes in Egypt, Arab Rep. in 1982 and the Number of enrolments of both sexes in Haiti in 1986?
Provide a succinct answer. 2.94e+06. What is the difference between the Number of enrolments of both sexes in Egypt, Arab Rep. in 1982 and the Number of enrolments of both sexes in United Kingdom in 1986?
Offer a terse response. -1.79e+06. What is the difference between the Number of enrolments of both sexes in Haiti in 1982 and the Number of enrolments of both sexes in United Kingdom in 1986?
Provide a succinct answer. -4.78e+06. What is the difference between the Number of enrolments of both sexes in South Asia in 1983 and the Number of enrolments of both sexes in Egypt, Arab Rep. in 1984?
Provide a short and direct response. 4.19e+07. What is the difference between the Number of enrolments of both sexes in South Asia in 1983 and the Number of enrolments of both sexes in Haiti in 1984?
Your answer should be compact. 4.52e+07. What is the difference between the Number of enrolments of both sexes in South Asia in 1983 and the Number of enrolments of both sexes in United Kingdom in 1984?
Offer a very short reply. 4.01e+07. What is the difference between the Number of enrolments of both sexes of Egypt, Arab Rep. in 1983 and the Number of enrolments of both sexes of Haiti in 1984?
Give a very brief answer. 3.11e+06. What is the difference between the Number of enrolments of both sexes in Egypt, Arab Rep. in 1983 and the Number of enrolments of both sexes in United Kingdom in 1984?
Offer a very short reply. -1.93e+06. What is the difference between the Number of enrolments of both sexes in Haiti in 1983 and the Number of enrolments of both sexes in United Kingdom in 1984?
Offer a very short reply. -5.05e+06. What is the difference between the Number of enrolments of both sexes of South Asia in 1983 and the Number of enrolments of both sexes of Egypt, Arab Rep. in 1986?
Make the answer very short. 4.15e+07. What is the difference between the Number of enrolments of both sexes in South Asia in 1983 and the Number of enrolments of both sexes in Haiti in 1986?
Keep it short and to the point. 4.52e+07. What is the difference between the Number of enrolments of both sexes of South Asia in 1983 and the Number of enrolments of both sexes of United Kingdom in 1986?
Make the answer very short. 4.04e+07. What is the difference between the Number of enrolments of both sexes in Egypt, Arab Rep. in 1983 and the Number of enrolments of both sexes in Haiti in 1986?
Your response must be concise. 3.10e+06. What is the difference between the Number of enrolments of both sexes in Egypt, Arab Rep. in 1983 and the Number of enrolments of both sexes in United Kingdom in 1986?
Provide a succinct answer. -1.63e+06. What is the difference between the Number of enrolments of both sexes in Haiti in 1983 and the Number of enrolments of both sexes in United Kingdom in 1986?
Offer a terse response. -4.76e+06. What is the difference between the Number of enrolments of both sexes in South Asia in 1984 and the Number of enrolments of both sexes in Egypt, Arab Rep. in 1986?
Your answer should be very brief. 4.43e+07. What is the difference between the Number of enrolments of both sexes in South Asia in 1984 and the Number of enrolments of both sexes in Haiti in 1986?
Ensure brevity in your answer.  4.79e+07. What is the difference between the Number of enrolments of both sexes of South Asia in 1984 and the Number of enrolments of both sexes of United Kingdom in 1986?
Provide a short and direct response. 4.32e+07. What is the difference between the Number of enrolments of both sexes in Egypt, Arab Rep. in 1984 and the Number of enrolments of both sexes in Haiti in 1986?
Your answer should be compact. 3.27e+06. What is the difference between the Number of enrolments of both sexes in Egypt, Arab Rep. in 1984 and the Number of enrolments of both sexes in United Kingdom in 1986?
Ensure brevity in your answer.  -1.46e+06. What is the difference between the Number of enrolments of both sexes of Haiti in 1984 and the Number of enrolments of both sexes of United Kingdom in 1986?
Ensure brevity in your answer.  -4.74e+06. What is the average Number of enrolments of both sexes of South Asia per year?
Your answer should be compact. 4.28e+07. What is the average Number of enrolments of both sexes of Egypt, Arab Rep. per year?
Ensure brevity in your answer.  3.14e+06. What is the average Number of enrolments of both sexes of Haiti per year?
Your answer should be very brief. 1.11e+05. What is the average Number of enrolments of both sexes of United Kingdom per year?
Provide a short and direct response. 5.25e+06. In the year 1979, what is the difference between the Number of enrolments of both sexes of South Asia and Number of enrolments of both sexes of Egypt, Arab Rep.?
Offer a very short reply. 3.24e+07. In the year 1979, what is the difference between the Number of enrolments of both sexes in South Asia and Number of enrolments of both sexes in Haiti?
Your answer should be very brief. 3.50e+07. In the year 1979, what is the difference between the Number of enrolments of both sexes in South Asia and Number of enrolments of both sexes in United Kingdom?
Your answer should be very brief. 2.97e+07. In the year 1979, what is the difference between the Number of enrolments of both sexes in Egypt, Arab Rep. and Number of enrolments of both sexes in Haiti?
Keep it short and to the point. 2.60e+06. In the year 1979, what is the difference between the Number of enrolments of both sexes of Egypt, Arab Rep. and Number of enrolments of both sexes of United Kingdom?
Make the answer very short. -2.70e+06. In the year 1979, what is the difference between the Number of enrolments of both sexes in Haiti and Number of enrolments of both sexes in United Kingdom?
Keep it short and to the point. -5.30e+06. In the year 1980, what is the difference between the Number of enrolments of both sexes of South Asia and Number of enrolments of both sexes of Egypt, Arab Rep.?
Make the answer very short. 3.46e+07. In the year 1980, what is the difference between the Number of enrolments of both sexes in South Asia and Number of enrolments of both sexes in Haiti?
Ensure brevity in your answer.  3.73e+07. In the year 1980, what is the difference between the Number of enrolments of both sexes in South Asia and Number of enrolments of both sexes in United Kingdom?
Make the answer very short. 3.21e+07. In the year 1980, what is the difference between the Number of enrolments of both sexes of Egypt, Arab Rep. and Number of enrolments of both sexes of Haiti?
Make the answer very short. 2.72e+06. In the year 1980, what is the difference between the Number of enrolments of both sexes in Egypt, Arab Rep. and Number of enrolments of both sexes in United Kingdom?
Give a very brief answer. -2.55e+06. In the year 1980, what is the difference between the Number of enrolments of both sexes of Haiti and Number of enrolments of both sexes of United Kingdom?
Make the answer very short. -5.27e+06. In the year 1981, what is the difference between the Number of enrolments of both sexes in South Asia and Number of enrolments of both sexes in Egypt, Arab Rep.?
Your answer should be very brief. 3.63e+07. In the year 1981, what is the difference between the Number of enrolments of both sexes of South Asia and Number of enrolments of both sexes of Haiti?
Your response must be concise. 3.92e+07. In the year 1981, what is the difference between the Number of enrolments of both sexes of South Asia and Number of enrolments of both sexes of United Kingdom?
Provide a short and direct response. 3.39e+07. In the year 1981, what is the difference between the Number of enrolments of both sexes of Egypt, Arab Rep. and Number of enrolments of both sexes of Haiti?
Offer a very short reply. 2.83e+06. In the year 1981, what is the difference between the Number of enrolments of both sexes of Egypt, Arab Rep. and Number of enrolments of both sexes of United Kingdom?
Ensure brevity in your answer.  -2.41e+06. In the year 1981, what is the difference between the Number of enrolments of both sexes of Haiti and Number of enrolments of both sexes of United Kingdom?
Ensure brevity in your answer.  -5.24e+06. In the year 1982, what is the difference between the Number of enrolments of both sexes of South Asia and Number of enrolments of both sexes of Egypt, Arab Rep.?
Provide a succinct answer. 3.87e+07. In the year 1982, what is the difference between the Number of enrolments of both sexes of South Asia and Number of enrolments of both sexes of Haiti?
Make the answer very short. 4.17e+07. In the year 1982, what is the difference between the Number of enrolments of both sexes in South Asia and Number of enrolments of both sexes in United Kingdom?
Ensure brevity in your answer.  3.65e+07. In the year 1982, what is the difference between the Number of enrolments of both sexes of Egypt, Arab Rep. and Number of enrolments of both sexes of Haiti?
Provide a succinct answer. 2.98e+06. In the year 1982, what is the difference between the Number of enrolments of both sexes of Egypt, Arab Rep. and Number of enrolments of both sexes of United Kingdom?
Provide a succinct answer. -2.24e+06. In the year 1982, what is the difference between the Number of enrolments of both sexes in Haiti and Number of enrolments of both sexes in United Kingdom?
Give a very brief answer. -5.23e+06. In the year 1983, what is the difference between the Number of enrolments of both sexes of South Asia and Number of enrolments of both sexes of Egypt, Arab Rep.?
Offer a terse response. 4.21e+07. In the year 1983, what is the difference between the Number of enrolments of both sexes in South Asia and Number of enrolments of both sexes in Haiti?
Your answer should be compact. 4.52e+07. In the year 1983, what is the difference between the Number of enrolments of both sexes of South Asia and Number of enrolments of both sexes of United Kingdom?
Your answer should be compact. 4.00e+07. In the year 1983, what is the difference between the Number of enrolments of both sexes in Egypt, Arab Rep. and Number of enrolments of both sexes in Haiti?
Your response must be concise. 3.13e+06. In the year 1983, what is the difference between the Number of enrolments of both sexes in Egypt, Arab Rep. and Number of enrolments of both sexes in United Kingdom?
Your response must be concise. -2.05e+06. In the year 1983, what is the difference between the Number of enrolments of both sexes in Haiti and Number of enrolments of both sexes in United Kingdom?
Your answer should be compact. -5.18e+06. In the year 1984, what is the difference between the Number of enrolments of both sexes in South Asia and Number of enrolments of both sexes in Egypt, Arab Rep.?
Ensure brevity in your answer.  4.47e+07. In the year 1984, what is the difference between the Number of enrolments of both sexes of South Asia and Number of enrolments of both sexes of Haiti?
Make the answer very short. 4.79e+07. In the year 1984, what is the difference between the Number of enrolments of both sexes of South Asia and Number of enrolments of both sexes of United Kingdom?
Ensure brevity in your answer.  4.29e+07. In the year 1984, what is the difference between the Number of enrolments of both sexes in Egypt, Arab Rep. and Number of enrolments of both sexes in Haiti?
Keep it short and to the point. 3.28e+06. In the year 1984, what is the difference between the Number of enrolments of both sexes in Egypt, Arab Rep. and Number of enrolments of both sexes in United Kingdom?
Your answer should be very brief. -1.76e+06. In the year 1984, what is the difference between the Number of enrolments of both sexes in Haiti and Number of enrolments of both sexes in United Kingdom?
Your answer should be compact. -5.04e+06. In the year 1986, what is the difference between the Number of enrolments of both sexes in South Asia and Number of enrolments of both sexes in Egypt, Arab Rep.?
Keep it short and to the point. 4.90e+07. In the year 1986, what is the difference between the Number of enrolments of both sexes in South Asia and Number of enrolments of both sexes in Haiti?
Offer a terse response. 5.27e+07. In the year 1986, what is the difference between the Number of enrolments of both sexes of South Asia and Number of enrolments of both sexes of United Kingdom?
Offer a very short reply. 4.79e+07. In the year 1986, what is the difference between the Number of enrolments of both sexes of Egypt, Arab Rep. and Number of enrolments of both sexes of Haiti?
Ensure brevity in your answer.  3.68e+06. In the year 1986, what is the difference between the Number of enrolments of both sexes of Egypt, Arab Rep. and Number of enrolments of both sexes of United Kingdom?
Make the answer very short. -1.05e+06. In the year 1986, what is the difference between the Number of enrolments of both sexes of Haiti and Number of enrolments of both sexes of United Kingdom?
Offer a terse response. -4.73e+06. What is the ratio of the Number of enrolments of both sexes in South Asia in 1979 to that in 1980?
Your answer should be very brief. 0.94. What is the ratio of the Number of enrolments of both sexes in Egypt, Arab Rep. in 1979 to that in 1980?
Your response must be concise. 0.96. What is the ratio of the Number of enrolments of both sexes in Haiti in 1979 to that in 1980?
Offer a very short reply. 0.93. What is the ratio of the Number of enrolments of both sexes of South Asia in 1979 to that in 1981?
Make the answer very short. 0.89. What is the ratio of the Number of enrolments of both sexes of Haiti in 1979 to that in 1981?
Your answer should be compact. 0.85. What is the ratio of the Number of enrolments of both sexes of United Kingdom in 1979 to that in 1981?
Provide a short and direct response. 1.01. What is the ratio of the Number of enrolments of both sexes in South Asia in 1979 to that in 1982?
Your answer should be compact. 0.84. What is the ratio of the Number of enrolments of both sexes of Egypt, Arab Rep. in 1979 to that in 1982?
Offer a terse response. 0.87. What is the ratio of the Number of enrolments of both sexes in Haiti in 1979 to that in 1982?
Your answer should be compact. 0.83. What is the ratio of the Number of enrolments of both sexes in United Kingdom in 1979 to that in 1982?
Keep it short and to the point. 1.01. What is the ratio of the Number of enrolments of both sexes of South Asia in 1979 to that in 1983?
Keep it short and to the point. 0.78. What is the ratio of the Number of enrolments of both sexes in Egypt, Arab Rep. in 1979 to that in 1983?
Offer a terse response. 0.83. What is the ratio of the Number of enrolments of both sexes of Haiti in 1979 to that in 1983?
Ensure brevity in your answer.  0.7. What is the ratio of the Number of enrolments of both sexes in South Asia in 1979 to that in 1984?
Your answer should be very brief. 0.73. What is the ratio of the Number of enrolments of both sexes of Egypt, Arab Rep. in 1979 to that in 1984?
Offer a terse response. 0.79. What is the ratio of the Number of enrolments of both sexes of Haiti in 1979 to that in 1984?
Provide a short and direct response. 0.61. What is the ratio of the Number of enrolments of both sexes of United Kingdom in 1979 to that in 1984?
Offer a very short reply. 1.04. What is the ratio of the Number of enrolments of both sexes of South Asia in 1979 to that in 1986?
Your response must be concise. 0.67. What is the ratio of the Number of enrolments of both sexes of Egypt, Arab Rep. in 1979 to that in 1986?
Make the answer very short. 0.7. What is the ratio of the Number of enrolments of both sexes in Haiti in 1979 to that in 1986?
Ensure brevity in your answer.  0.59. What is the ratio of the Number of enrolments of both sexes in United Kingdom in 1979 to that in 1986?
Provide a succinct answer. 1.1. What is the ratio of the Number of enrolments of both sexes in South Asia in 1980 to that in 1981?
Provide a succinct answer. 0.95. What is the ratio of the Number of enrolments of both sexes in Haiti in 1980 to that in 1981?
Offer a very short reply. 0.91. What is the ratio of the Number of enrolments of both sexes of South Asia in 1980 to that in 1982?
Make the answer very short. 0.9. What is the ratio of the Number of enrolments of both sexes in Egypt, Arab Rep. in 1980 to that in 1982?
Your answer should be very brief. 0.91. What is the ratio of the Number of enrolments of both sexes in Haiti in 1980 to that in 1982?
Offer a very short reply. 0.9. What is the ratio of the Number of enrolments of both sexes of United Kingdom in 1980 to that in 1982?
Keep it short and to the point. 1.01. What is the ratio of the Number of enrolments of both sexes in South Asia in 1980 to that in 1983?
Provide a succinct answer. 0.83. What is the ratio of the Number of enrolments of both sexes of Egypt, Arab Rep. in 1980 to that in 1983?
Ensure brevity in your answer.  0.86. What is the ratio of the Number of enrolments of both sexes in Haiti in 1980 to that in 1983?
Keep it short and to the point. 0.76. What is the ratio of the Number of enrolments of both sexes of United Kingdom in 1980 to that in 1983?
Provide a succinct answer. 1.01. What is the ratio of the Number of enrolments of both sexes in South Asia in 1980 to that in 1984?
Provide a succinct answer. 0.78. What is the ratio of the Number of enrolments of both sexes of Egypt, Arab Rep. in 1980 to that in 1984?
Offer a terse response. 0.82. What is the ratio of the Number of enrolments of both sexes of Haiti in 1980 to that in 1984?
Give a very brief answer. 0.66. What is the ratio of the Number of enrolments of both sexes in United Kingdom in 1980 to that in 1984?
Your answer should be very brief. 1.04. What is the ratio of the Number of enrolments of both sexes in South Asia in 1980 to that in 1986?
Provide a short and direct response. 0.71. What is the ratio of the Number of enrolments of both sexes of Egypt, Arab Rep. in 1980 to that in 1986?
Give a very brief answer. 0.73. What is the ratio of the Number of enrolments of both sexes of Haiti in 1980 to that in 1986?
Make the answer very short. 0.63. What is the ratio of the Number of enrolments of both sexes in United Kingdom in 1980 to that in 1986?
Ensure brevity in your answer.  1.1. What is the ratio of the Number of enrolments of both sexes in South Asia in 1981 to that in 1982?
Your answer should be very brief. 0.94. What is the ratio of the Number of enrolments of both sexes in Egypt, Arab Rep. in 1981 to that in 1982?
Provide a succinct answer. 0.95. What is the ratio of the Number of enrolments of both sexes of South Asia in 1981 to that in 1983?
Your answer should be compact. 0.87. What is the ratio of the Number of enrolments of both sexes in Egypt, Arab Rep. in 1981 to that in 1983?
Offer a terse response. 0.9. What is the ratio of the Number of enrolments of both sexes in Haiti in 1981 to that in 1983?
Offer a very short reply. 0.83. What is the ratio of the Number of enrolments of both sexes of United Kingdom in 1981 to that in 1983?
Ensure brevity in your answer.  1.01. What is the ratio of the Number of enrolments of both sexes in South Asia in 1981 to that in 1984?
Ensure brevity in your answer.  0.82. What is the ratio of the Number of enrolments of both sexes in Egypt, Arab Rep. in 1981 to that in 1984?
Your answer should be compact. 0.86. What is the ratio of the Number of enrolments of both sexes in Haiti in 1981 to that in 1984?
Keep it short and to the point. 0.73. What is the ratio of the Number of enrolments of both sexes of United Kingdom in 1981 to that in 1984?
Provide a short and direct response. 1.03. What is the ratio of the Number of enrolments of both sexes in South Asia in 1981 to that in 1986?
Give a very brief answer. 0.74. What is the ratio of the Number of enrolments of both sexes of Egypt, Arab Rep. in 1981 to that in 1986?
Give a very brief answer. 0.77. What is the ratio of the Number of enrolments of both sexes of Haiti in 1981 to that in 1986?
Offer a terse response. 0.69. What is the ratio of the Number of enrolments of both sexes of United Kingdom in 1981 to that in 1986?
Provide a short and direct response. 1.1. What is the ratio of the Number of enrolments of both sexes of South Asia in 1982 to that in 1983?
Give a very brief answer. 0.92. What is the ratio of the Number of enrolments of both sexes in Egypt, Arab Rep. in 1982 to that in 1983?
Provide a succinct answer. 0.95. What is the ratio of the Number of enrolments of both sexes in Haiti in 1982 to that in 1983?
Make the answer very short. 0.84. What is the ratio of the Number of enrolments of both sexes in South Asia in 1982 to that in 1984?
Offer a very short reply. 0.87. What is the ratio of the Number of enrolments of both sexes of Egypt, Arab Rep. in 1982 to that in 1984?
Offer a terse response. 0.9. What is the ratio of the Number of enrolments of both sexes in Haiti in 1982 to that in 1984?
Ensure brevity in your answer.  0.74. What is the ratio of the Number of enrolments of both sexes of United Kingdom in 1982 to that in 1984?
Make the answer very short. 1.03. What is the ratio of the Number of enrolments of both sexes of South Asia in 1982 to that in 1986?
Provide a succinct answer. 0.79. What is the ratio of the Number of enrolments of both sexes in Egypt, Arab Rep. in 1982 to that in 1986?
Provide a succinct answer. 0.81. What is the ratio of the Number of enrolments of both sexes in Haiti in 1982 to that in 1986?
Offer a very short reply. 0.71. What is the ratio of the Number of enrolments of both sexes of United Kingdom in 1982 to that in 1986?
Give a very brief answer. 1.09. What is the ratio of the Number of enrolments of both sexes in South Asia in 1983 to that in 1984?
Keep it short and to the point. 0.94. What is the ratio of the Number of enrolments of both sexes of Egypt, Arab Rep. in 1983 to that in 1984?
Your answer should be compact. 0.95. What is the ratio of the Number of enrolments of both sexes in Haiti in 1983 to that in 1984?
Provide a succinct answer. 0.87. What is the ratio of the Number of enrolments of both sexes of United Kingdom in 1983 to that in 1984?
Provide a succinct answer. 1.02. What is the ratio of the Number of enrolments of both sexes of South Asia in 1983 to that in 1986?
Make the answer very short. 0.86. What is the ratio of the Number of enrolments of both sexes in Egypt, Arab Rep. in 1983 to that in 1986?
Keep it short and to the point. 0.85. What is the ratio of the Number of enrolments of both sexes of Haiti in 1983 to that in 1986?
Give a very brief answer. 0.84. What is the ratio of the Number of enrolments of both sexes in United Kingdom in 1983 to that in 1986?
Give a very brief answer. 1.09. What is the ratio of the Number of enrolments of both sexes in South Asia in 1984 to that in 1986?
Your response must be concise. 0.91. What is the ratio of the Number of enrolments of both sexes of Egypt, Arab Rep. in 1984 to that in 1986?
Give a very brief answer. 0.89. What is the ratio of the Number of enrolments of both sexes in Haiti in 1984 to that in 1986?
Give a very brief answer. 0.96. What is the ratio of the Number of enrolments of both sexes in United Kingdom in 1984 to that in 1986?
Make the answer very short. 1.06. What is the difference between the highest and the second highest Number of enrolments of both sexes in South Asia?
Give a very brief answer. 4.73e+06. What is the difference between the highest and the second highest Number of enrolments of both sexes of Egypt, Arab Rep.?
Your answer should be compact. 4.12e+05. What is the difference between the highest and the second highest Number of enrolments of both sexes in Haiti?
Offer a terse response. 6245. What is the difference between the highest and the second highest Number of enrolments of both sexes in United Kingdom?
Make the answer very short. 2.07e+04. What is the difference between the highest and the lowest Number of enrolments of both sexes in South Asia?
Provide a succinct answer. 1.77e+07. What is the difference between the highest and the lowest Number of enrolments of both sexes of Egypt, Arab Rep.?
Your response must be concise. 1.14e+06. What is the difference between the highest and the lowest Number of enrolments of both sexes in Haiti?
Provide a succinct answer. 5.93e+04. What is the difference between the highest and the lowest Number of enrolments of both sexes in United Kingdom?
Provide a short and direct response. 5.04e+05. 